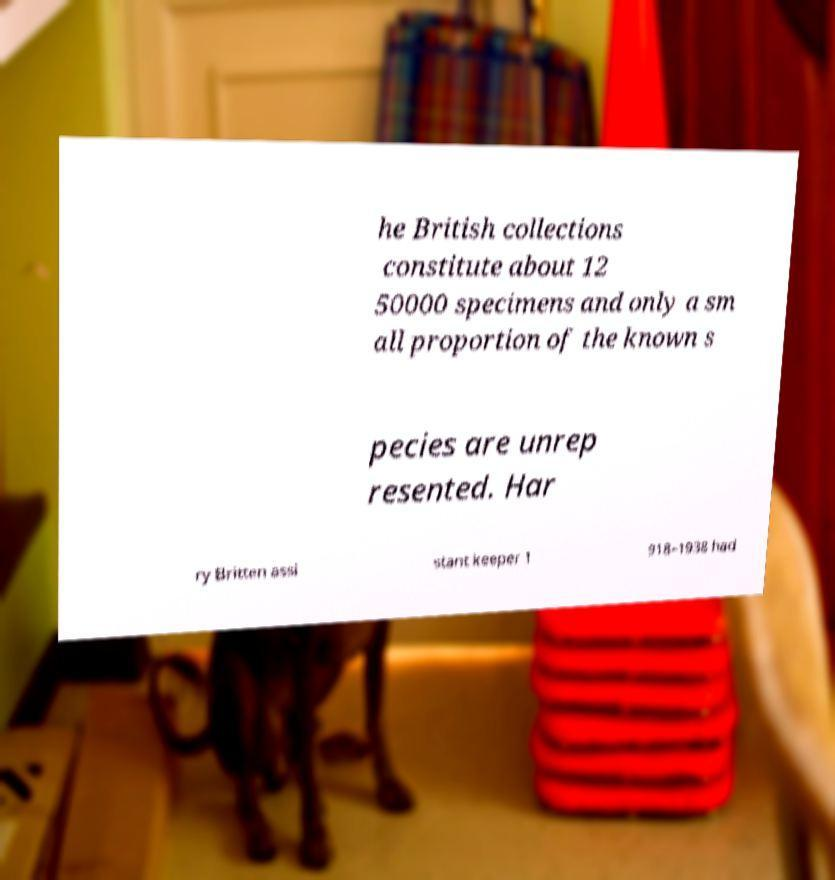Please read and relay the text visible in this image. What does it say? he British collections constitute about 12 50000 specimens and only a sm all proportion of the known s pecies are unrep resented. Har ry Britten assi stant keeper 1 918–1938 had 